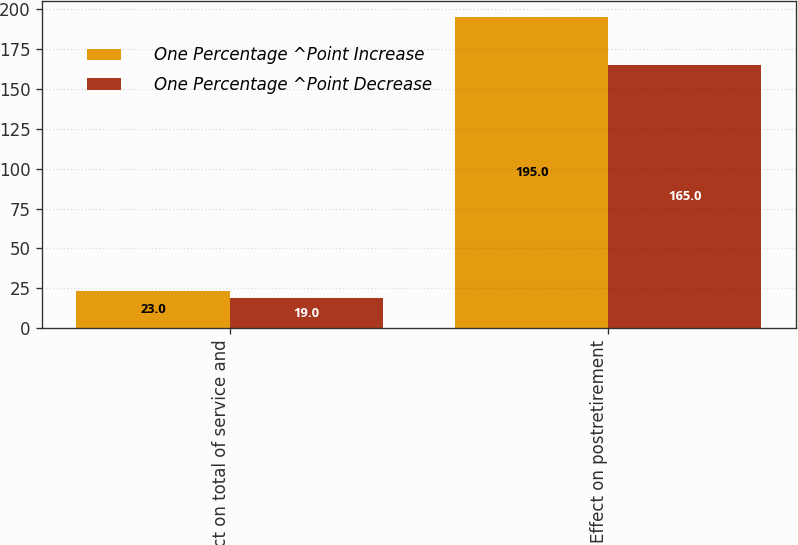Convert chart to OTSL. <chart><loc_0><loc_0><loc_500><loc_500><stacked_bar_chart><ecel><fcel>Effect on total of service and<fcel>Effect on postretirement<nl><fcel>One Percentage ^Point Increase<fcel>23<fcel>195<nl><fcel>One Percentage ^Point Decrease<fcel>19<fcel>165<nl></chart> 